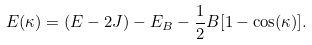<formula> <loc_0><loc_0><loc_500><loc_500>E ( \kappa ) = ( E - 2 J ) - E _ { B } - \frac { 1 } { 2 } B [ 1 - \cos ( \kappa ) ] .</formula> 